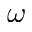Convert formula to latex. <formula><loc_0><loc_0><loc_500><loc_500>\omega</formula> 